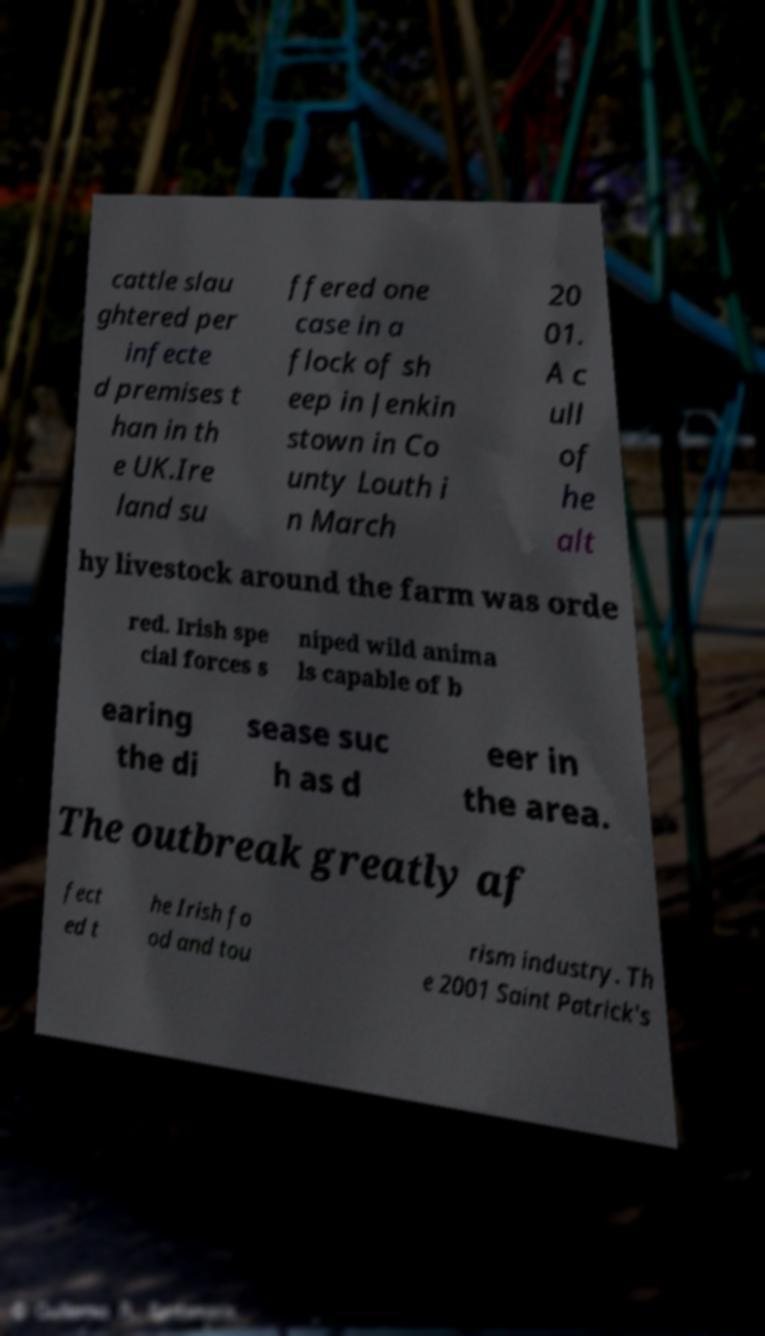Could you assist in decoding the text presented in this image and type it out clearly? cattle slau ghtered per infecte d premises t han in th e UK.Ire land su ffered one case in a flock of sh eep in Jenkin stown in Co unty Louth i n March 20 01. A c ull of he alt hy livestock around the farm was orde red. Irish spe cial forces s niped wild anima ls capable of b earing the di sease suc h as d eer in the area. The outbreak greatly af fect ed t he Irish fo od and tou rism industry. Th e 2001 Saint Patrick's 